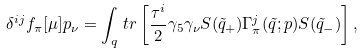<formula> <loc_0><loc_0><loc_500><loc_500>\delta ^ { i j } f _ { \pi } [ \mu ] p _ { \nu } = \int _ { q } \, t r \left [ \frac { \tau ^ { i } } { 2 } \gamma _ { 5 } \gamma _ { \nu } S ( \tilde { q } _ { + } ) \Gamma _ { \pi } ^ { j } ( \tilde { q } ; p ) S ( \tilde { q } _ { - } ) \right ] ,</formula> 